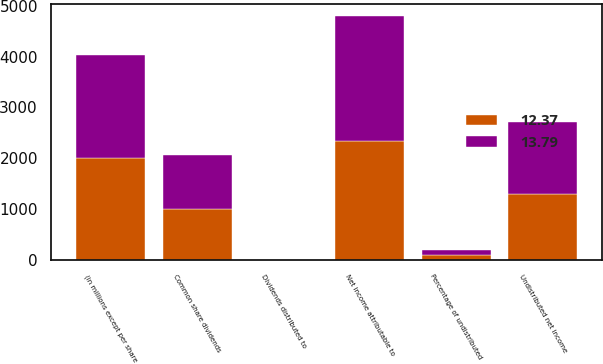Convert chart to OTSL. <chart><loc_0><loc_0><loc_500><loc_500><stacked_bar_chart><ecel><fcel>(in millions except per share<fcel>Net income attributable to<fcel>Dividends distributed to<fcel>Undistributed net income<fcel>Percentage of undistributed<fcel>Common share dividends<nl><fcel>13.79<fcel>2012<fcel>2458<fcel>1<fcel>1396<fcel>99.9<fcel>1059<nl><fcel>12.37<fcel>2011<fcel>2337<fcel>10<fcel>1311<fcel>99.1<fcel>1004<nl></chart> 